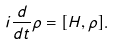Convert formula to latex. <formula><loc_0><loc_0><loc_500><loc_500>i \frac { d } { d t } \rho = [ H , \rho ] .</formula> 